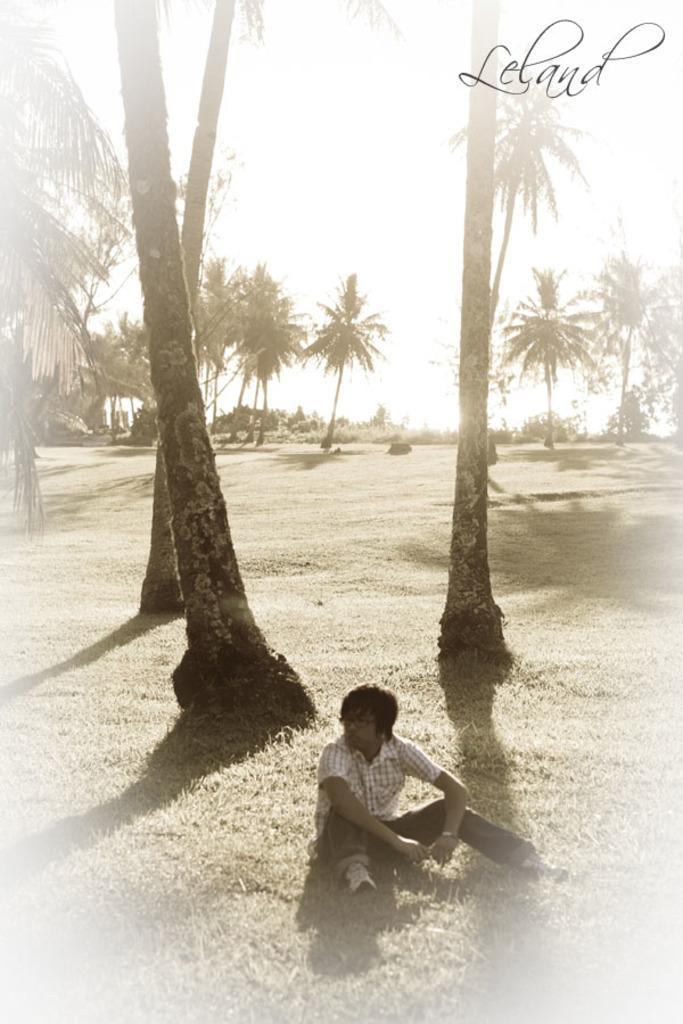Could you give a brief overview of what you see in this image? In this image we can see a man is sitting on the grassy land. Behind the man, trees and plants are there. We can see watermark in the right top of the image. 